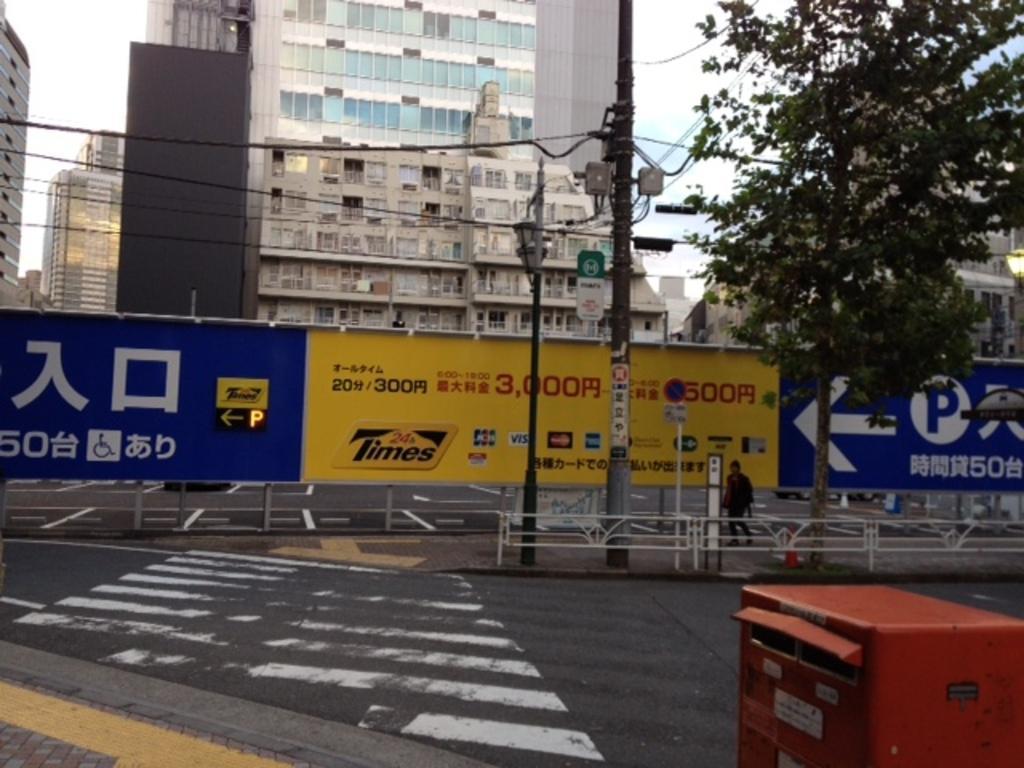Can you describe this image briefly? This picture is clicked outside. In the foreground there is a zebra crossing, metal rods, red color box, a person walking on the ground and we can see the cables, poles, banners and we can see the text on the banners. In the background there is a sky, tree and buildings. 